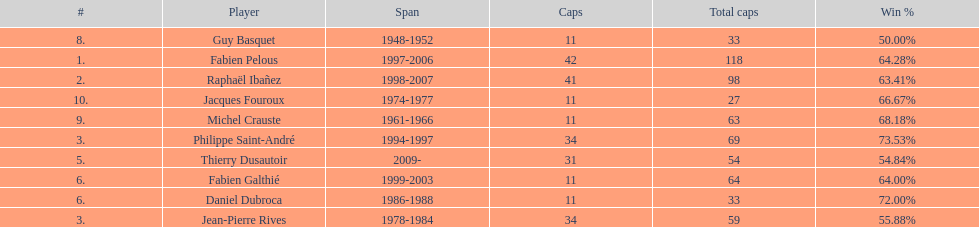Which captain served the least amount of time? Daniel Dubroca. 